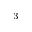<formula> <loc_0><loc_0><loc_500><loc_500>^ { - 3 }</formula> 